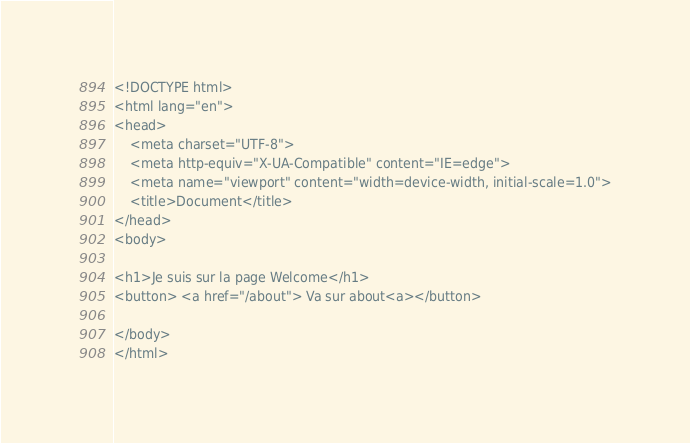<code> <loc_0><loc_0><loc_500><loc_500><_PHP_><!DOCTYPE html>
<html lang="en">
<head>
    <meta charset="UTF-8">
    <meta http-equiv="X-UA-Compatible" content="IE=edge">
    <meta name="viewport" content="width=device-width, initial-scale=1.0">
    <title>Document</title>
</head>
<body>

<h1>Je suis sur la page Welcome</h1>
<button> <a href="/about"> Va sur about<a></button>

</body>
</html></code> 